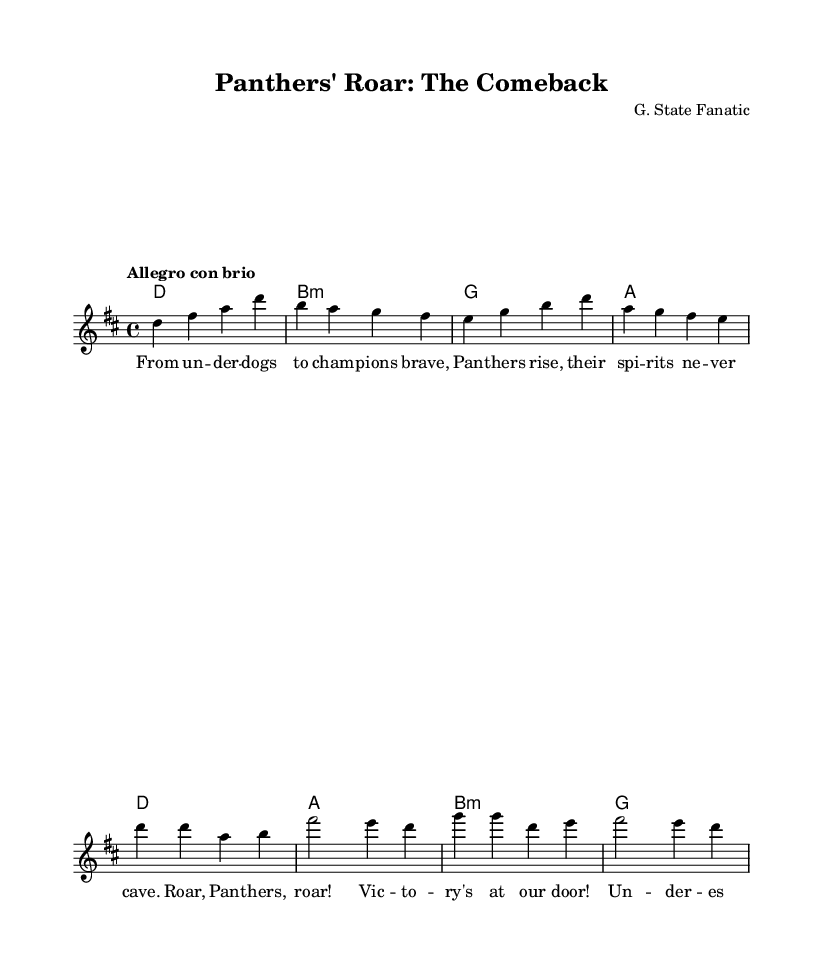What is the key signature of this music? The key signature indicated at the beginning of the score is D major, which has two sharps (F# and C#).
Answer: D major What is the time signature of this music? The time signature at the beginning is 4/4, meaning there are four beats in each measure, and the quarter note receives one beat.
Answer: 4/4 What is the tempo marking for this piece? The tempo marking provided in the score is "Allegro con brio," which implies a lively and spirited style of play.
Answer: Allegro con brio How many measures are in the melody section? Counting the measures in the melody part, there are eight measures; this includes both the main theme and the chorus.
Answer: 8 What thematic element is emphasized in the lyrics? The lyrics emphasize the theme of overcoming adversity and achieving victory, highlighting the journey from being underdogs to champions.
Answer: Underdogs to champions What type of musical composition is this? This composition is classified as an opera, specifically focused on a narrative of sports underdogs and their triumphs.
Answer: Opera Which instrument is primarily featured in this score? The score features a staff specifically for vocal melody, indicating an operatic performance where the primary instrument is the voice.
Answer: Voice 